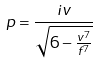Convert formula to latex. <formula><loc_0><loc_0><loc_500><loc_500>p = \frac { i v } { \sqrt { 6 - \frac { v ^ { 7 } } { f ^ { 7 } } } }</formula> 